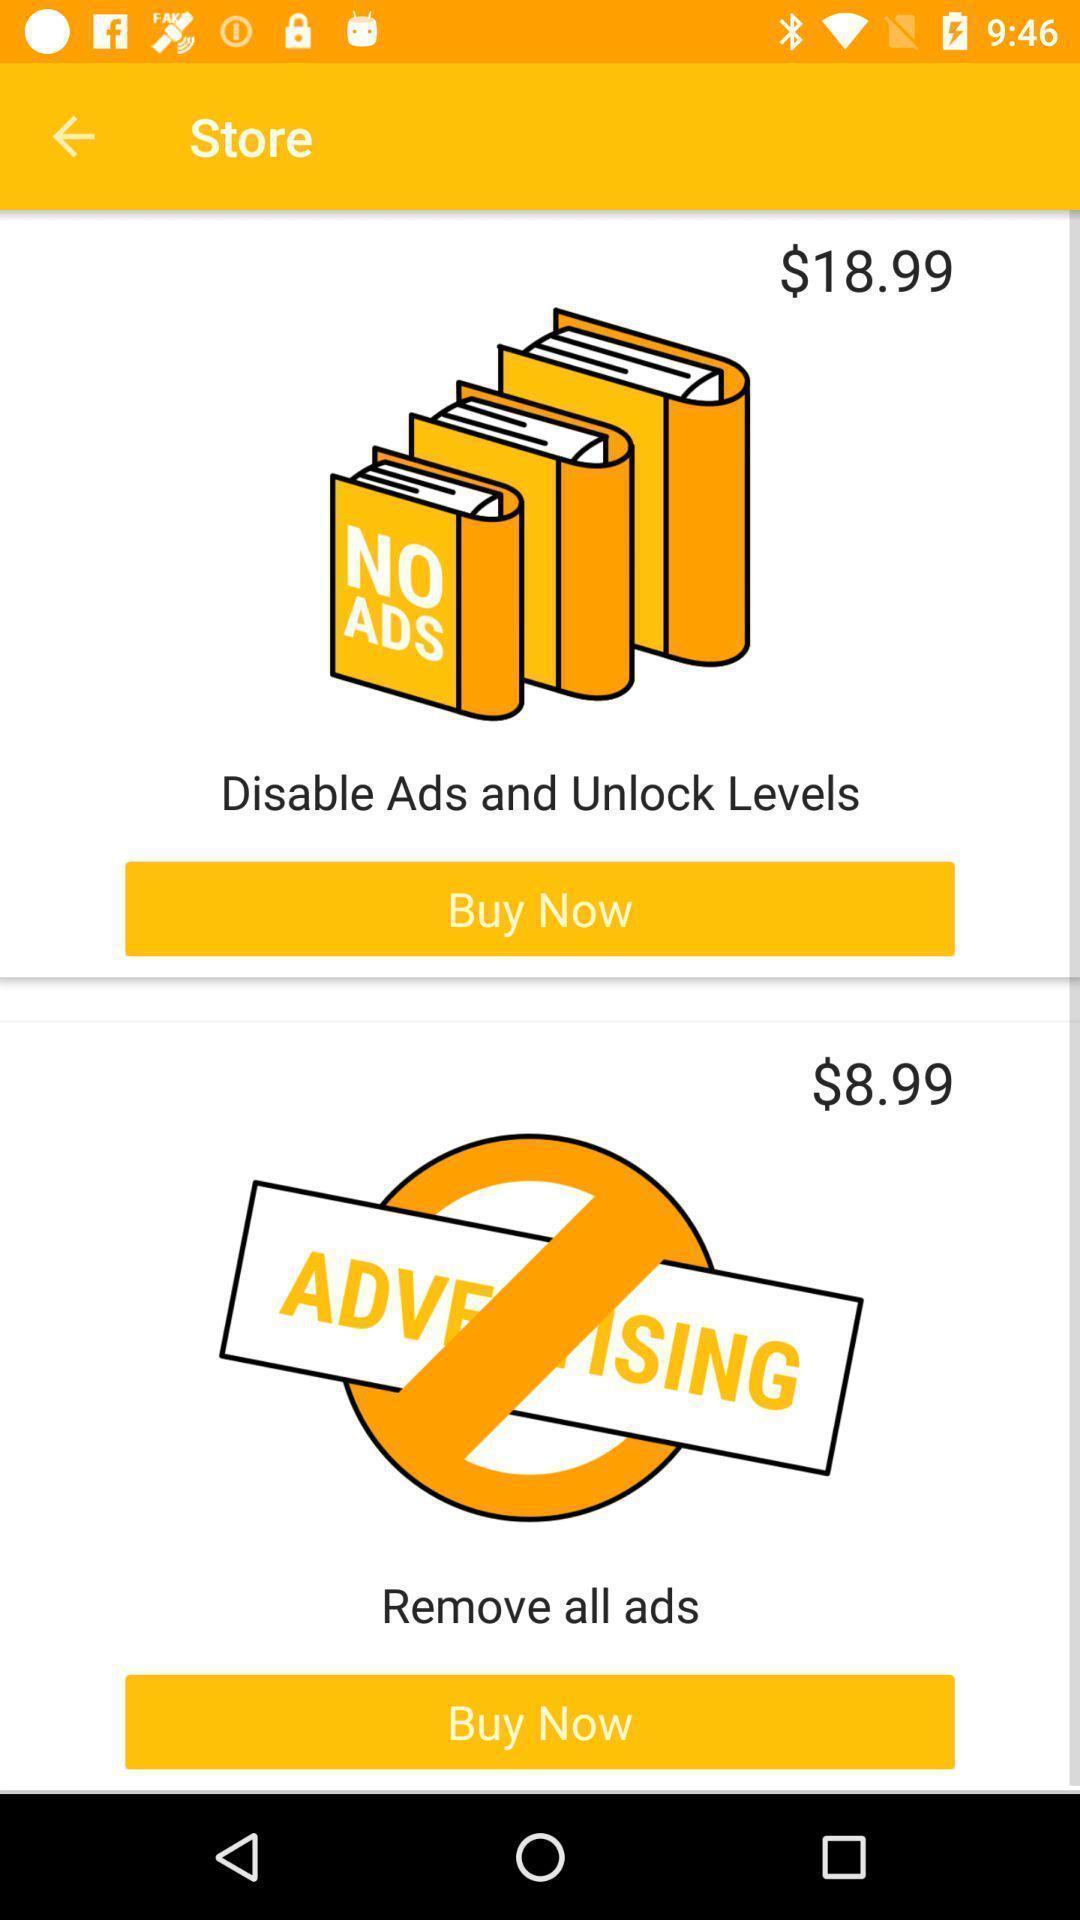Tell me about the visual elements in this screen capture. Shopping page of the store. 